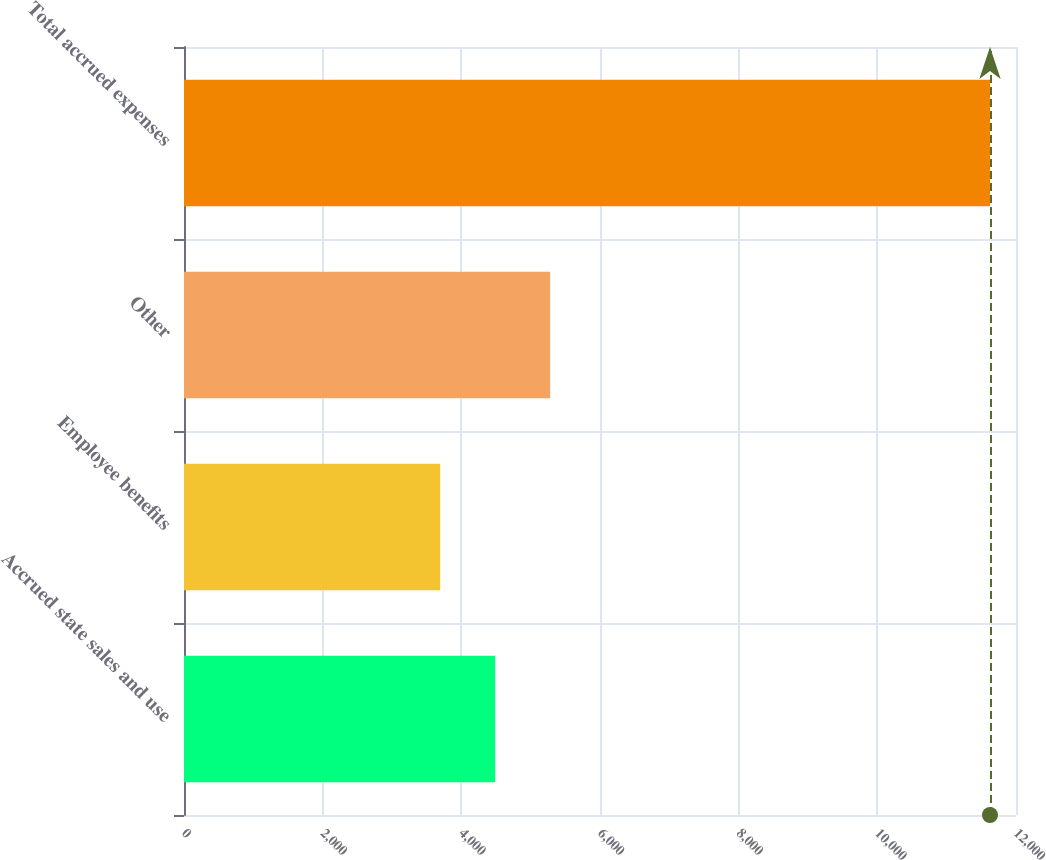Convert chart. <chart><loc_0><loc_0><loc_500><loc_500><bar_chart><fcel>Accrued state sales and use<fcel>Employee benefits<fcel>Other<fcel>Total accrued expenses<nl><fcel>4488<fcel>3695<fcel>5281<fcel>11625<nl></chart> 